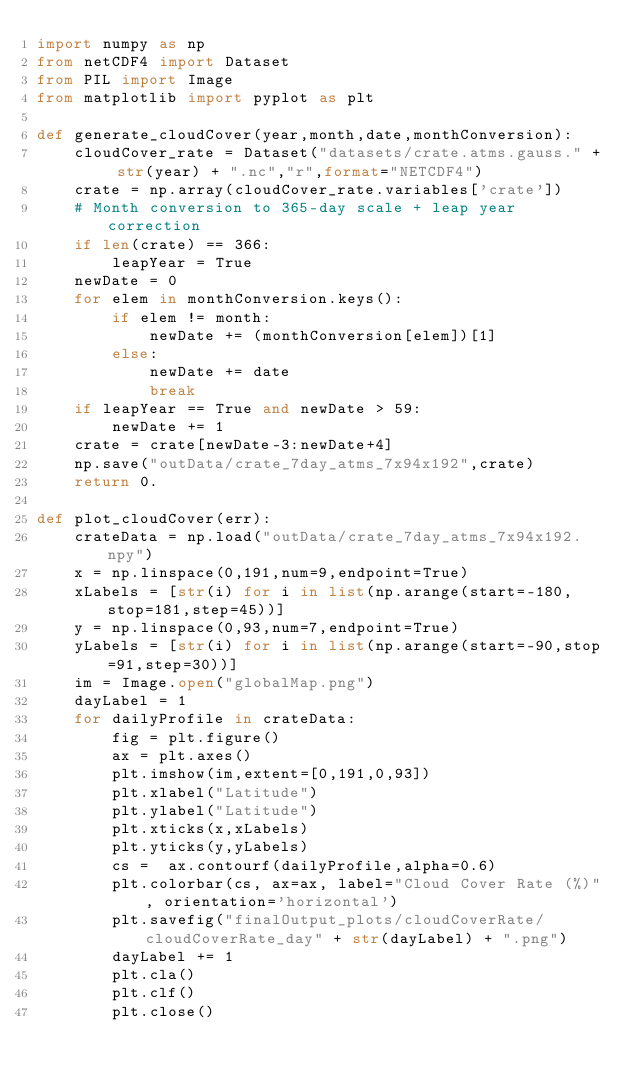<code> <loc_0><loc_0><loc_500><loc_500><_Python_>import numpy as np
from netCDF4 import Dataset
from PIL import Image
from matplotlib import pyplot as plt

def generate_cloudCover(year,month,date,monthConversion):
	cloudCover_rate = Dataset("datasets/crate.atms.gauss." + str(year) + ".nc","r",format="NETCDF4")
	crate = np.array(cloudCover_rate.variables['crate'])
	# Month conversion to 365-day scale + leap year correction
	if len(crate) == 366:
		leapYear = True
	newDate = 0
	for elem in monthConversion.keys():
		if elem != month:
			newDate += (monthConversion[elem])[1]
		else:
			newDate += date
			break
	if leapYear == True and newDate > 59:
		newDate += 1
	crate = crate[newDate-3:newDate+4]
	np.save("outData/crate_7day_atms_7x94x192",crate)
	return 0.

def plot_cloudCover(err):
	crateData = np.load("outData/crate_7day_atms_7x94x192.npy")
	x = np.linspace(0,191,num=9,endpoint=True)
	xLabels = [str(i) for i in list(np.arange(start=-180,stop=181,step=45))]
	y = np.linspace(0,93,num=7,endpoint=True)
	yLabels = [str(i) for i in list(np.arange(start=-90,stop=91,step=30))]
	im = Image.open("globalMap.png")
	dayLabel = 1
	for dailyProfile in crateData:
		fig = plt.figure()
		ax = plt.axes()
		plt.imshow(im,extent=[0,191,0,93])
		plt.xlabel("Latitude")
		plt.ylabel("Latitude")
		plt.xticks(x,xLabels)
		plt.yticks(y,yLabels)
		cs =  ax.contourf(dailyProfile,alpha=0.6)
		plt.colorbar(cs, ax=ax, label="Cloud Cover Rate (%)", orientation='horizontal')
		plt.savefig("finalOutput_plots/cloudCoverRate/cloudCoverRate_day" + str(dayLabel) + ".png")
		dayLabel += 1
		plt.cla()
		plt.clf()
		plt.close()</code> 